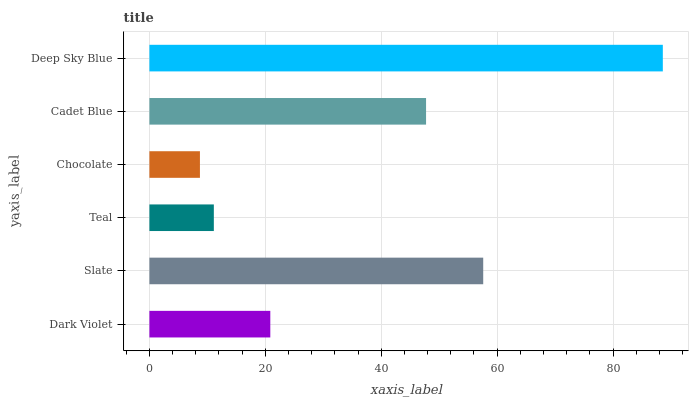Is Chocolate the minimum?
Answer yes or no. Yes. Is Deep Sky Blue the maximum?
Answer yes or no. Yes. Is Slate the minimum?
Answer yes or no. No. Is Slate the maximum?
Answer yes or no. No. Is Slate greater than Dark Violet?
Answer yes or no. Yes. Is Dark Violet less than Slate?
Answer yes or no. Yes. Is Dark Violet greater than Slate?
Answer yes or no. No. Is Slate less than Dark Violet?
Answer yes or no. No. Is Cadet Blue the high median?
Answer yes or no. Yes. Is Dark Violet the low median?
Answer yes or no. Yes. Is Deep Sky Blue the high median?
Answer yes or no. No. Is Chocolate the low median?
Answer yes or no. No. 